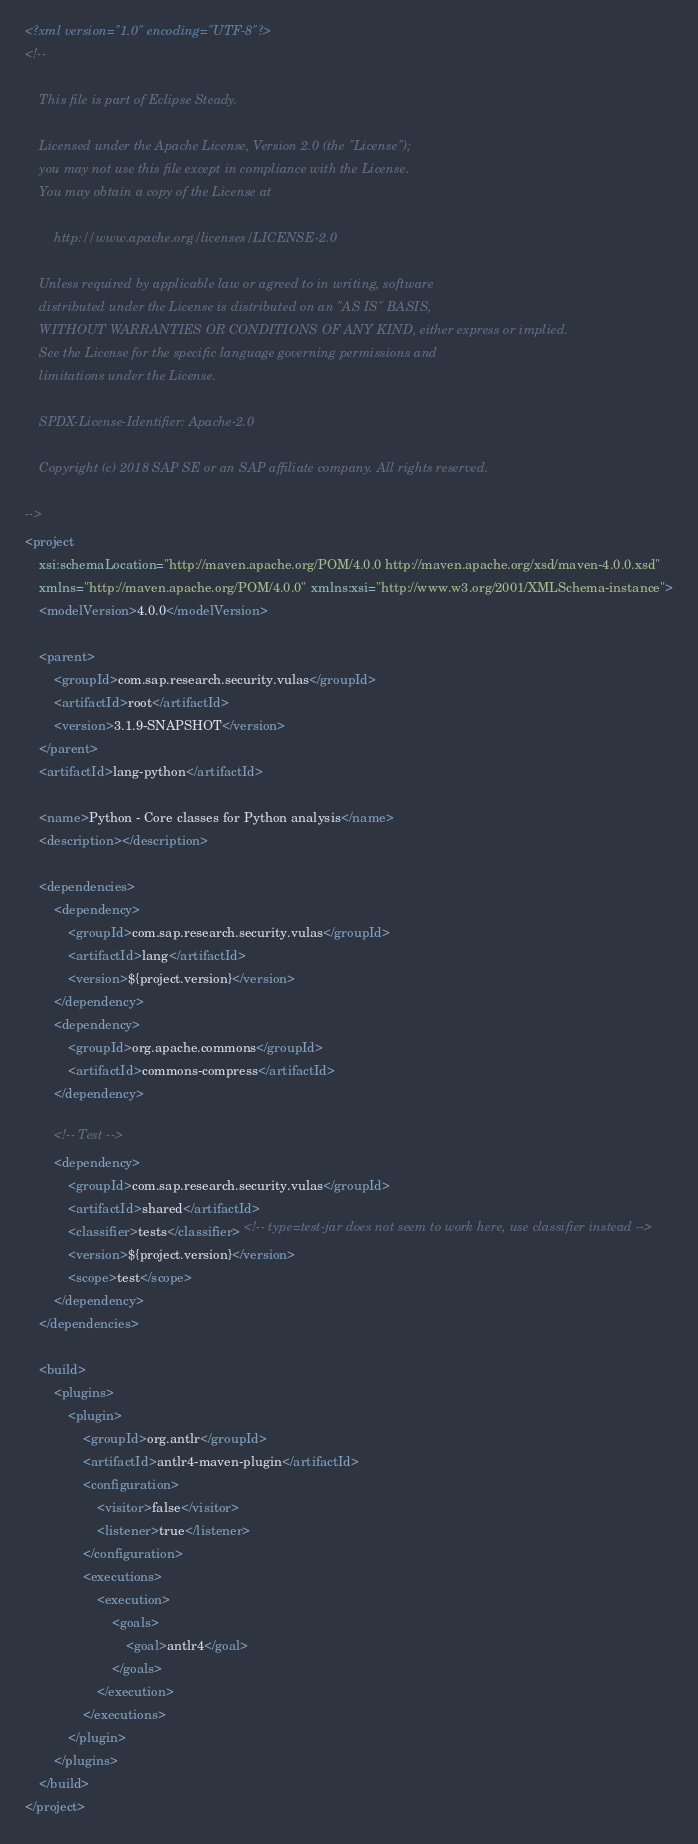<code> <loc_0><loc_0><loc_500><loc_500><_XML_><?xml version="1.0" encoding="UTF-8"?>
<!--

    This file is part of Eclipse Steady.

    Licensed under the Apache License, Version 2.0 (the "License");
    you may not use this file except in compliance with the License.
    You may obtain a copy of the License at

        http://www.apache.org/licenses/LICENSE-2.0

    Unless required by applicable law or agreed to in writing, software
    distributed under the License is distributed on an "AS IS" BASIS,
    WITHOUT WARRANTIES OR CONDITIONS OF ANY KIND, either express or implied.
    See the License for the specific language governing permissions and
    limitations under the License.

    SPDX-License-Identifier: Apache-2.0

    Copyright (c) 2018 SAP SE or an SAP affiliate company. All rights reserved.

-->
<project
	xsi:schemaLocation="http://maven.apache.org/POM/4.0.0 http://maven.apache.org/xsd/maven-4.0.0.xsd"
	xmlns="http://maven.apache.org/POM/4.0.0" xmlns:xsi="http://www.w3.org/2001/XMLSchema-instance">
	<modelVersion>4.0.0</modelVersion>

	<parent>
		<groupId>com.sap.research.security.vulas</groupId>
		<artifactId>root</artifactId>
		<version>3.1.9-SNAPSHOT</version>
	</parent>
	<artifactId>lang-python</artifactId>

	<name>Python - Core classes for Python analysis</name>
	<description></description>

	<dependencies>
		<dependency>
			<groupId>com.sap.research.security.vulas</groupId>
			<artifactId>lang</artifactId>
			<version>${project.version}</version>
		</dependency>
		<dependency>
			<groupId>org.apache.commons</groupId>
			<artifactId>commons-compress</artifactId>
		</dependency>

		<!-- Test -->
		<dependency>
			<groupId>com.sap.research.security.vulas</groupId>
			<artifactId>shared</artifactId>
			<classifier>tests</classifier> <!-- type=test-jar does not seem to work here, use classifier instead -->
			<version>${project.version}</version>
			<scope>test</scope>
		</dependency>
	</dependencies>
	
	<build>
		<plugins>			
			<plugin>
				<groupId>org.antlr</groupId>
				<artifactId>antlr4-maven-plugin</artifactId>
				<configuration>
					<visitor>false</visitor>
					<listener>true</listener>
				</configuration>
				<executions>
					<execution>
						<goals>
							<goal>antlr4</goal>
						</goals>
					</execution>
				</executions>
			</plugin>
		</plugins>
	</build>
</project>
</code> 